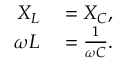<formula> <loc_0><loc_0><loc_500><loc_500>\begin{array} { r l } { X _ { L } } & = X _ { C } , } \\ { \omega L } & = { \frac { 1 } { \omega C } } . } \end{array}</formula> 